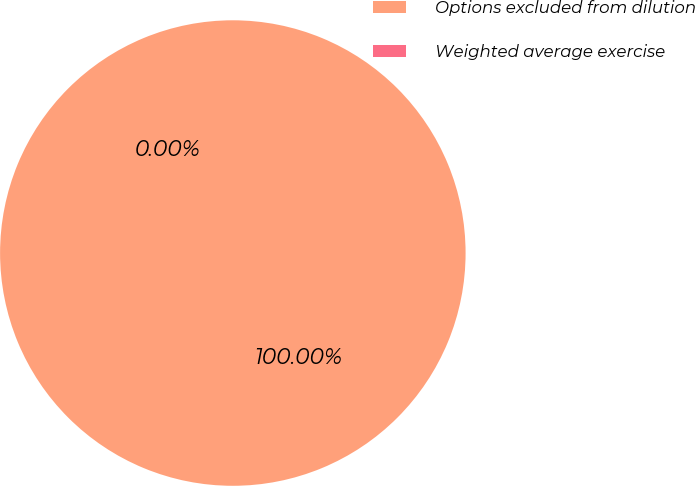Convert chart. <chart><loc_0><loc_0><loc_500><loc_500><pie_chart><fcel>Options excluded from dilution<fcel>Weighted average exercise<nl><fcel>100.0%<fcel>0.0%<nl></chart> 